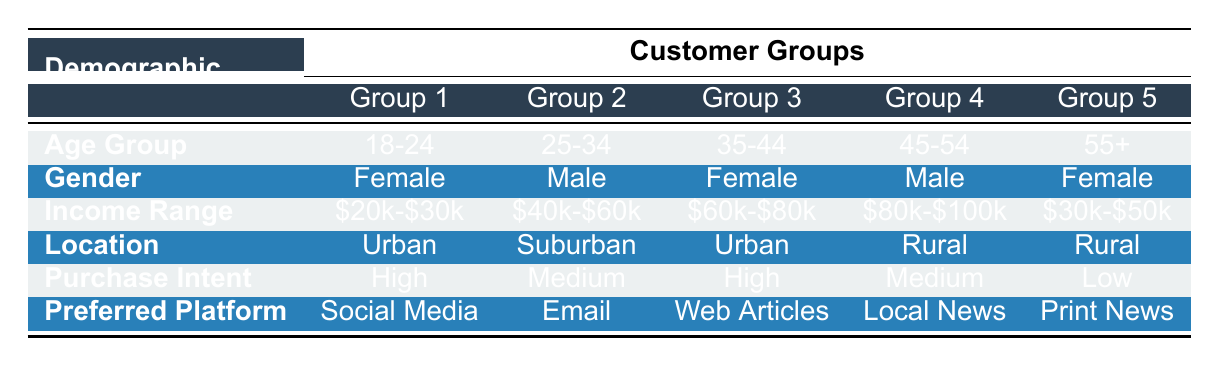What is the purchase intent of the 45-54 age group? According to the table, the purchase intent of the 45-54 age group is labeled as "Medium."
Answer: Medium Which age group prefers social media as their platform? The table shows that the 18-24 age group has "Social Media" listed as their preferred platform.
Answer: 18-24 Is there any female demographic in the 35-44 age group? Yes, the table confirms that the 35-44 age group is categorized under "Female."
Answer: Yes What is the income range of the 25-34 age group? The income range listed for the 25-34 age group is "$40,000 - $60,000" according to the table.
Answer: $40,000 - $60,000 Count how many groups have high purchase intent. By reviewing the table, both the 18-24 and 35-44 age groups have "High" purchase intent, making a total of 2 groups with this characteristic.
Answer: 2 Which group has the lowest purchase intent? The table indicates that the 55+ age group has "Low" purchase intent, making it the group with the lowest.
Answer: 55+ Do males prefer web articles according to this data? No, the table indicates that the preferred platform for both male groups (25-34 and 45-54) is "Email Newsletters" and "Local Newspaper," respectively.
Answer: No What is the most common location among customers in the table? The table lists two urban locations for the 18-24 and 35-44 age groups, suggesting that "Urban" is the most common location among customers.
Answer: Urban What are the income ranges for those with high purchase intent? The table shows that the income ranges for the two groups with high purchase intent (18-24 and 35-44) are "$20,000 - $30,000" and "$60,000 - $80,000," respectively.
Answer: $20,000 - $30,000; $60,000 - $80,000 Which preferred platform is associated with the lowest purchase intent? The table shows that "Print Newspaper" is the preferred platform listed for the 55+ age group, which has the lowest purchase intent.
Answer: Print Newspaper 